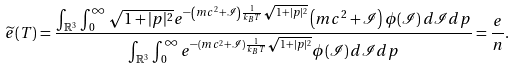<formula> <loc_0><loc_0><loc_500><loc_500>\widetilde { e } ( T ) = \frac { \int _ { \mathbb { R } ^ { 3 } } \int _ { 0 } ^ { \infty } \sqrt { 1 + | p | ^ { 2 } } e ^ { - \left ( m c ^ { 2 } + \mathcal { I } \right ) \frac { 1 } { k _ { B } T } \sqrt { 1 + | p | ^ { 2 } } } \left ( m c ^ { 2 } + \mathcal { I } \right ) \phi ( \mathcal { I } ) \, d \mathcal { I } d p } { \int _ { \mathbb { R } ^ { 3 } } \int _ { 0 } ^ { \infty } e ^ { - \left ( m c ^ { 2 } + \mathcal { I } \right ) \frac { 1 } { k _ { B } T } \sqrt { 1 + | p | ^ { 2 } } } \phi ( \mathcal { I } ) \, d \mathcal { I } d p } = \frac { e } { n } .</formula> 